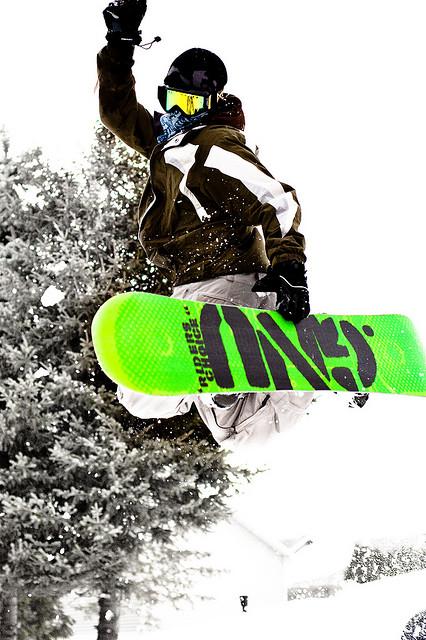What color is the snowboard?
Be succinct. Green. What is on the man's face?
Short answer required. Goggles. What season does this photo represent?
Quick response, please. Winter. 